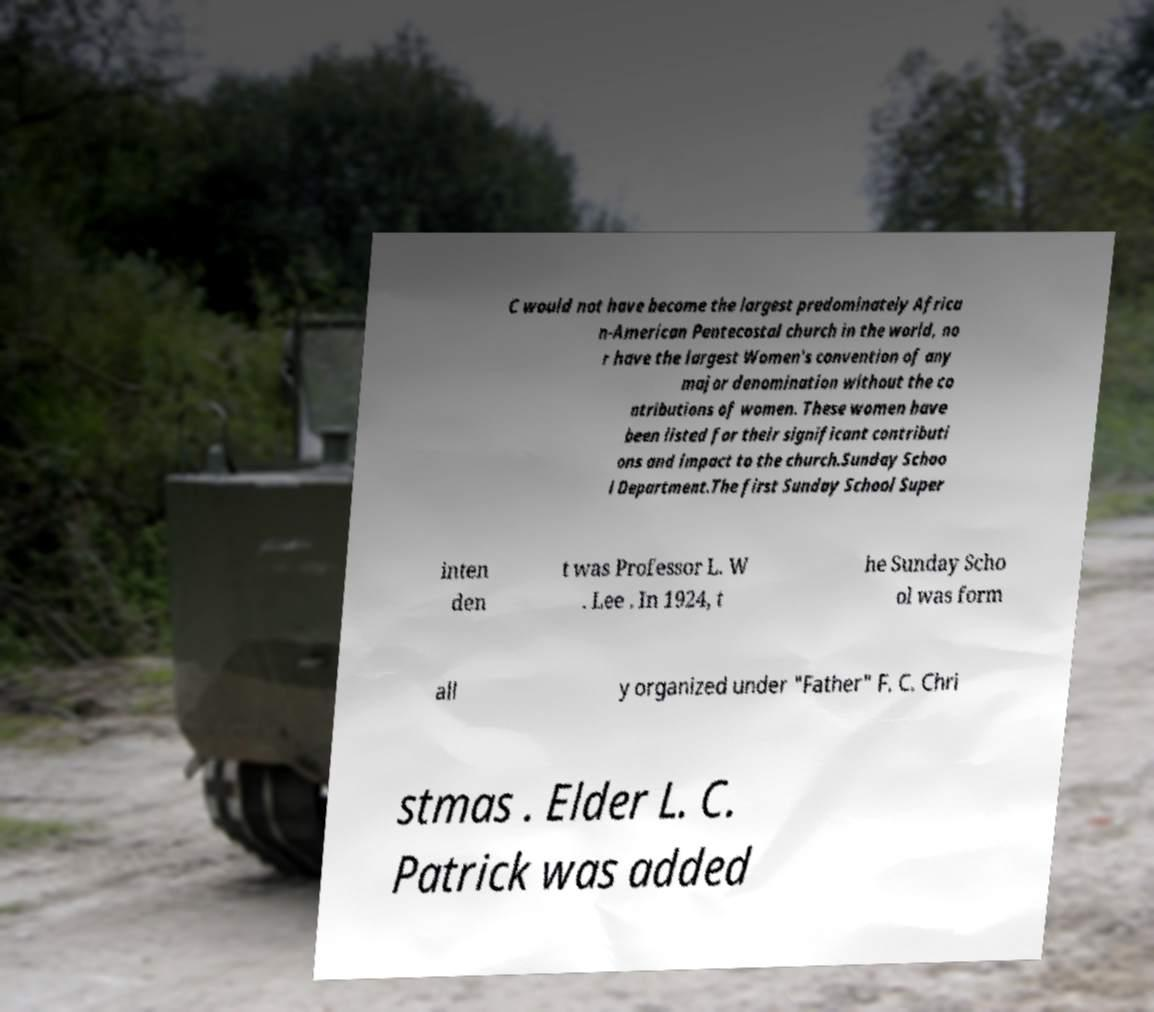Could you extract and type out the text from this image? C would not have become the largest predominately Africa n-American Pentecostal church in the world, no r have the largest Women's convention of any major denomination without the co ntributions of women. These women have been listed for their significant contributi ons and impact to the church.Sunday Schoo l Department.The first Sunday School Super inten den t was Professor L. W . Lee . In 1924, t he Sunday Scho ol was form all y organized under "Father" F. C. Chri stmas . Elder L. C. Patrick was added 